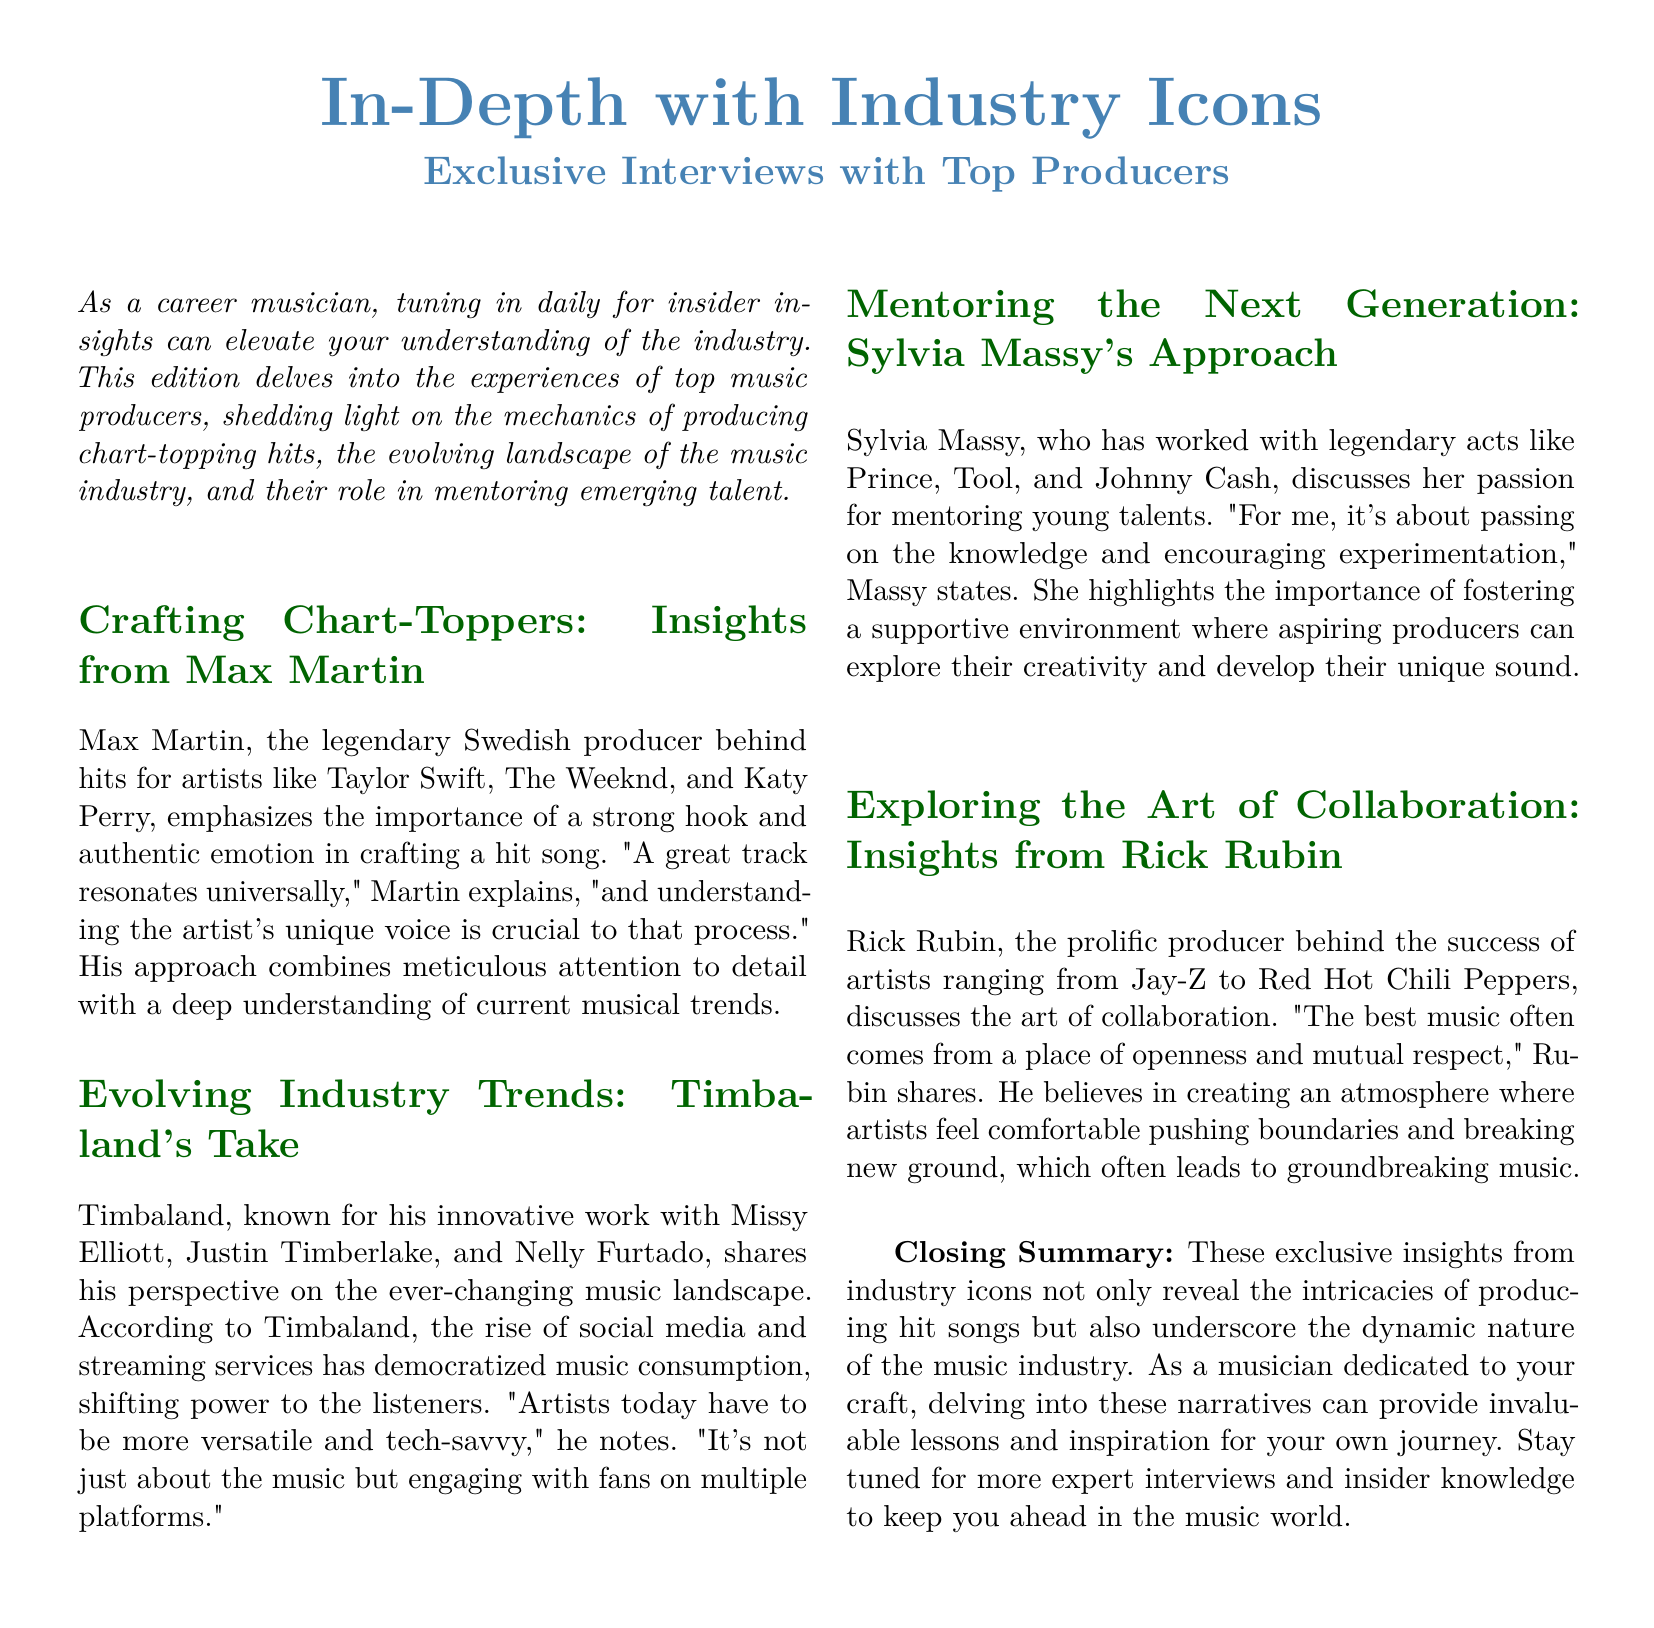What is the title of the document? The title is prominently displayed at the top of the document.
Answer: In-Depth with Industry Icons Who is featured in the exclusive interviews section? The document mentions several renowned music producers who are the focus of the interviews.
Answer: Top Producers Which producer emphasizes the importance of a strong hook? The document states that this producer shares insights about crafting hit songs.
Answer: Max Martin What aspect of the music industry does Timbaland discuss? The text points out Timbaland's views on the changes brought by new technologies.
Answer: Evolving Industry Trends Who does Sylvia Massy mention she works with? The document lists prominent artists that Sylvia Massy has collaborated with throughout her career.
Answer: Prince, Tool, Johnny Cash What does Rick Rubin believe is crucial for producing great music? The document summarizes Rubin's perspective on collaboration in music.
Answer: Openness and mutual respect What is the main takeaway from the closing summary? This question seeks to summarize the overall message conveyed in the conclusion of the document.
Answer: Invaluable lessons and inspiration What is emphasized about artists today according to Timbaland? The document highlights an important point Timbaland makes about modern artists and their skills.
Answer: Be versatile and tech-savvy 